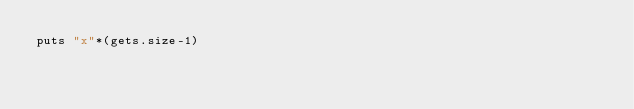Convert code to text. <code><loc_0><loc_0><loc_500><loc_500><_Ruby_>puts "x"*(gets.size-1)</code> 